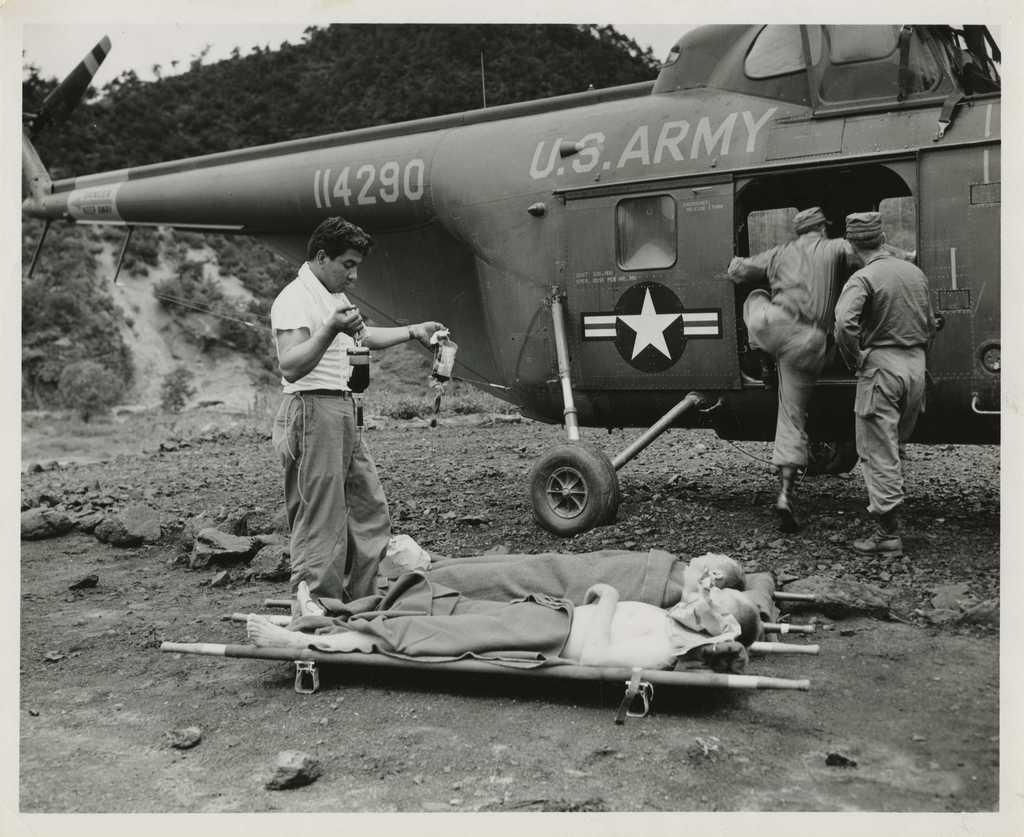Provide a one-sentence caption for the provided image. Men about to transport two other men onto a U.S. Army helicopter. 